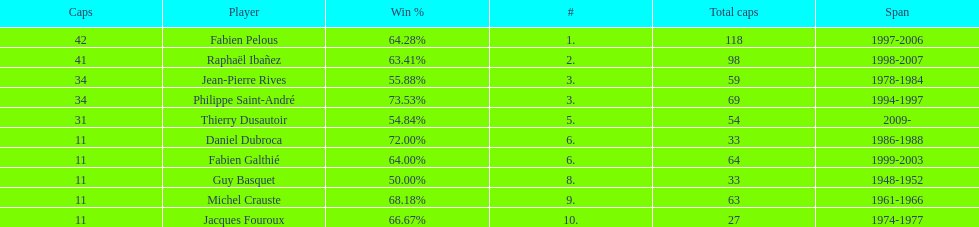How many captains played 11 capped matches? 5. 